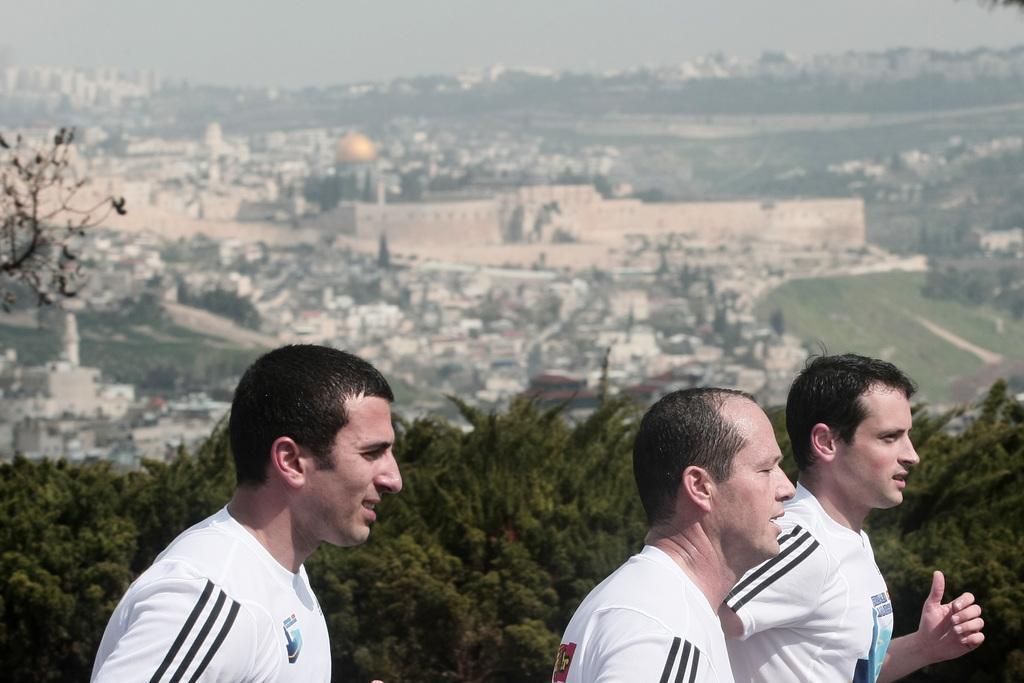In one or two sentences, can you explain what this image depicts? In this image I can see three persons, they are wearing white color shirt. Background I can see trees in green color, few buildings and the sky is in white color. 